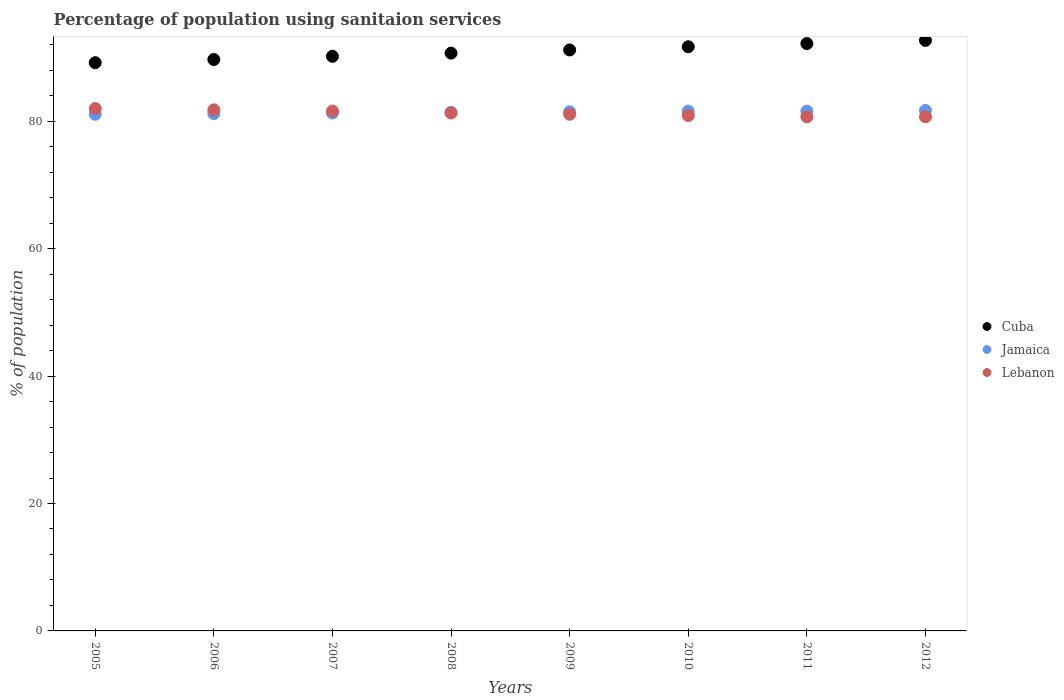What is the percentage of population using sanitaion services in Cuba in 2009?
Give a very brief answer. 91.2. Across all years, what is the maximum percentage of population using sanitaion services in Jamaica?
Give a very brief answer. 81.7. Across all years, what is the minimum percentage of population using sanitaion services in Lebanon?
Your answer should be very brief. 80.7. In which year was the percentage of population using sanitaion services in Jamaica minimum?
Your answer should be compact. 2005. What is the total percentage of population using sanitaion services in Cuba in the graph?
Offer a very short reply. 727.6. What is the difference between the percentage of population using sanitaion services in Jamaica in 2005 and that in 2008?
Offer a terse response. -0.3. What is the average percentage of population using sanitaion services in Cuba per year?
Keep it short and to the point. 90.95. In the year 2005, what is the difference between the percentage of population using sanitaion services in Cuba and percentage of population using sanitaion services in Lebanon?
Offer a terse response. 7.2. What is the ratio of the percentage of population using sanitaion services in Lebanon in 2005 to that in 2007?
Your response must be concise. 1. What is the difference between the highest and the second highest percentage of population using sanitaion services in Lebanon?
Your answer should be compact. 0.2. What is the difference between the highest and the lowest percentage of population using sanitaion services in Jamaica?
Keep it short and to the point. 0.6. Is it the case that in every year, the sum of the percentage of population using sanitaion services in Jamaica and percentage of population using sanitaion services in Cuba  is greater than the percentage of population using sanitaion services in Lebanon?
Give a very brief answer. Yes. Does the percentage of population using sanitaion services in Jamaica monotonically increase over the years?
Ensure brevity in your answer.  No. Is the percentage of population using sanitaion services in Cuba strictly greater than the percentage of population using sanitaion services in Lebanon over the years?
Ensure brevity in your answer.  Yes. Is the percentage of population using sanitaion services in Lebanon strictly less than the percentage of population using sanitaion services in Cuba over the years?
Offer a terse response. Yes. Are the values on the major ticks of Y-axis written in scientific E-notation?
Offer a very short reply. No. Does the graph contain any zero values?
Provide a succinct answer. No. What is the title of the graph?
Your answer should be compact. Percentage of population using sanitaion services. What is the label or title of the Y-axis?
Keep it short and to the point. % of population. What is the % of population of Cuba in 2005?
Make the answer very short. 89.2. What is the % of population in Jamaica in 2005?
Your answer should be compact. 81.1. What is the % of population of Lebanon in 2005?
Offer a very short reply. 82. What is the % of population in Cuba in 2006?
Offer a terse response. 89.7. What is the % of population in Jamaica in 2006?
Offer a very short reply. 81.2. What is the % of population in Lebanon in 2006?
Your response must be concise. 81.8. What is the % of population in Cuba in 2007?
Your answer should be compact. 90.2. What is the % of population of Jamaica in 2007?
Make the answer very short. 81.3. What is the % of population of Lebanon in 2007?
Ensure brevity in your answer.  81.6. What is the % of population in Cuba in 2008?
Offer a terse response. 90.7. What is the % of population in Jamaica in 2008?
Your response must be concise. 81.4. What is the % of population in Lebanon in 2008?
Your answer should be very brief. 81.3. What is the % of population in Cuba in 2009?
Provide a succinct answer. 91.2. What is the % of population in Jamaica in 2009?
Your response must be concise. 81.5. What is the % of population of Lebanon in 2009?
Provide a succinct answer. 81.1. What is the % of population of Cuba in 2010?
Your answer should be compact. 91.7. What is the % of population in Jamaica in 2010?
Ensure brevity in your answer.  81.6. What is the % of population of Lebanon in 2010?
Make the answer very short. 80.9. What is the % of population of Cuba in 2011?
Ensure brevity in your answer.  92.2. What is the % of population in Jamaica in 2011?
Ensure brevity in your answer.  81.6. What is the % of population of Lebanon in 2011?
Provide a succinct answer. 80.7. What is the % of population of Cuba in 2012?
Your response must be concise. 92.7. What is the % of population of Jamaica in 2012?
Keep it short and to the point. 81.7. What is the % of population in Lebanon in 2012?
Provide a succinct answer. 80.7. Across all years, what is the maximum % of population in Cuba?
Provide a short and direct response. 92.7. Across all years, what is the maximum % of population of Jamaica?
Provide a short and direct response. 81.7. Across all years, what is the maximum % of population in Lebanon?
Keep it short and to the point. 82. Across all years, what is the minimum % of population in Cuba?
Give a very brief answer. 89.2. Across all years, what is the minimum % of population in Jamaica?
Ensure brevity in your answer.  81.1. Across all years, what is the minimum % of population of Lebanon?
Make the answer very short. 80.7. What is the total % of population in Cuba in the graph?
Give a very brief answer. 727.6. What is the total % of population in Jamaica in the graph?
Your answer should be very brief. 651.4. What is the total % of population of Lebanon in the graph?
Make the answer very short. 650.1. What is the difference between the % of population of Jamaica in 2005 and that in 2006?
Ensure brevity in your answer.  -0.1. What is the difference between the % of population of Lebanon in 2005 and that in 2006?
Keep it short and to the point. 0.2. What is the difference between the % of population of Jamaica in 2005 and that in 2007?
Ensure brevity in your answer.  -0.2. What is the difference between the % of population of Lebanon in 2005 and that in 2008?
Your answer should be compact. 0.7. What is the difference between the % of population in Lebanon in 2005 and that in 2009?
Provide a short and direct response. 0.9. What is the difference between the % of population of Cuba in 2005 and that in 2010?
Offer a very short reply. -2.5. What is the difference between the % of population of Jamaica in 2005 and that in 2010?
Your answer should be compact. -0.5. What is the difference between the % of population of Lebanon in 2005 and that in 2010?
Provide a succinct answer. 1.1. What is the difference between the % of population of Cuba in 2005 and that in 2011?
Provide a succinct answer. -3. What is the difference between the % of population of Cuba in 2005 and that in 2012?
Offer a very short reply. -3.5. What is the difference between the % of population of Jamaica in 2005 and that in 2012?
Your answer should be compact. -0.6. What is the difference between the % of population of Lebanon in 2006 and that in 2007?
Provide a succinct answer. 0.2. What is the difference between the % of population in Jamaica in 2006 and that in 2008?
Keep it short and to the point. -0.2. What is the difference between the % of population of Lebanon in 2006 and that in 2008?
Provide a short and direct response. 0.5. What is the difference between the % of population of Jamaica in 2006 and that in 2009?
Your answer should be compact. -0.3. What is the difference between the % of population of Cuba in 2006 and that in 2010?
Provide a succinct answer. -2. What is the difference between the % of population in Jamaica in 2006 and that in 2010?
Your response must be concise. -0.4. What is the difference between the % of population of Lebanon in 2006 and that in 2010?
Give a very brief answer. 0.9. What is the difference between the % of population in Lebanon in 2006 and that in 2011?
Provide a succinct answer. 1.1. What is the difference between the % of population in Cuba in 2006 and that in 2012?
Ensure brevity in your answer.  -3. What is the difference between the % of population of Lebanon in 2006 and that in 2012?
Provide a short and direct response. 1.1. What is the difference between the % of population of Jamaica in 2007 and that in 2008?
Ensure brevity in your answer.  -0.1. What is the difference between the % of population in Lebanon in 2007 and that in 2008?
Offer a terse response. 0.3. What is the difference between the % of population of Cuba in 2007 and that in 2009?
Keep it short and to the point. -1. What is the difference between the % of population of Cuba in 2007 and that in 2010?
Keep it short and to the point. -1.5. What is the difference between the % of population of Jamaica in 2007 and that in 2011?
Keep it short and to the point. -0.3. What is the difference between the % of population of Jamaica in 2008 and that in 2009?
Keep it short and to the point. -0.1. What is the difference between the % of population of Cuba in 2008 and that in 2010?
Keep it short and to the point. -1. What is the difference between the % of population in Lebanon in 2008 and that in 2010?
Keep it short and to the point. 0.4. What is the difference between the % of population in Cuba in 2008 and that in 2011?
Give a very brief answer. -1.5. What is the difference between the % of population of Jamaica in 2008 and that in 2011?
Your answer should be very brief. -0.2. What is the difference between the % of population in Lebanon in 2008 and that in 2011?
Your response must be concise. 0.6. What is the difference between the % of population in Jamaica in 2008 and that in 2012?
Offer a terse response. -0.3. What is the difference between the % of population in Lebanon in 2008 and that in 2012?
Provide a succinct answer. 0.6. What is the difference between the % of population of Cuba in 2009 and that in 2010?
Make the answer very short. -0.5. What is the difference between the % of population in Jamaica in 2009 and that in 2010?
Your response must be concise. -0.1. What is the difference between the % of population in Lebanon in 2009 and that in 2010?
Provide a succinct answer. 0.2. What is the difference between the % of population in Cuba in 2009 and that in 2011?
Offer a terse response. -1. What is the difference between the % of population in Jamaica in 2009 and that in 2012?
Keep it short and to the point. -0.2. What is the difference between the % of population of Lebanon in 2009 and that in 2012?
Your response must be concise. 0.4. What is the difference between the % of population of Cuba in 2010 and that in 2011?
Offer a very short reply. -0.5. What is the difference between the % of population in Jamaica in 2010 and that in 2012?
Make the answer very short. -0.1. What is the difference between the % of population in Lebanon in 2010 and that in 2012?
Give a very brief answer. 0.2. What is the difference between the % of population of Cuba in 2005 and the % of population of Jamaica in 2007?
Keep it short and to the point. 7.9. What is the difference between the % of population of Jamaica in 2005 and the % of population of Lebanon in 2007?
Offer a very short reply. -0.5. What is the difference between the % of population of Cuba in 2005 and the % of population of Jamaica in 2008?
Offer a terse response. 7.8. What is the difference between the % of population in Cuba in 2005 and the % of population in Lebanon in 2008?
Your answer should be compact. 7.9. What is the difference between the % of population in Jamaica in 2005 and the % of population in Lebanon in 2009?
Provide a succinct answer. 0. What is the difference between the % of population in Cuba in 2005 and the % of population in Jamaica in 2010?
Provide a short and direct response. 7.6. What is the difference between the % of population in Jamaica in 2005 and the % of population in Lebanon in 2010?
Provide a succinct answer. 0.2. What is the difference between the % of population in Cuba in 2005 and the % of population in Jamaica in 2011?
Make the answer very short. 7.6. What is the difference between the % of population in Jamaica in 2005 and the % of population in Lebanon in 2011?
Keep it short and to the point. 0.4. What is the difference between the % of population in Cuba in 2005 and the % of population in Lebanon in 2012?
Make the answer very short. 8.5. What is the difference between the % of population of Jamaica in 2005 and the % of population of Lebanon in 2012?
Give a very brief answer. 0.4. What is the difference between the % of population of Cuba in 2006 and the % of population of Lebanon in 2007?
Ensure brevity in your answer.  8.1. What is the difference between the % of population of Cuba in 2006 and the % of population of Jamaica in 2009?
Provide a succinct answer. 8.2. What is the difference between the % of population of Cuba in 2006 and the % of population of Lebanon in 2009?
Keep it short and to the point. 8.6. What is the difference between the % of population in Jamaica in 2006 and the % of population in Lebanon in 2009?
Keep it short and to the point. 0.1. What is the difference between the % of population in Cuba in 2006 and the % of population in Jamaica in 2010?
Provide a short and direct response. 8.1. What is the difference between the % of population of Cuba in 2006 and the % of population of Lebanon in 2010?
Offer a terse response. 8.8. What is the difference between the % of population of Jamaica in 2006 and the % of population of Lebanon in 2010?
Your answer should be compact. 0.3. What is the difference between the % of population of Cuba in 2006 and the % of population of Jamaica in 2011?
Your answer should be very brief. 8.1. What is the difference between the % of population in Jamaica in 2006 and the % of population in Lebanon in 2011?
Your answer should be very brief. 0.5. What is the difference between the % of population in Cuba in 2006 and the % of population in Jamaica in 2012?
Give a very brief answer. 8. What is the difference between the % of population of Jamaica in 2007 and the % of population of Lebanon in 2008?
Provide a succinct answer. 0. What is the difference between the % of population of Cuba in 2007 and the % of population of Jamaica in 2009?
Ensure brevity in your answer.  8.7. What is the difference between the % of population of Cuba in 2007 and the % of population of Lebanon in 2010?
Provide a short and direct response. 9.3. What is the difference between the % of population in Jamaica in 2007 and the % of population in Lebanon in 2010?
Give a very brief answer. 0.4. What is the difference between the % of population in Jamaica in 2007 and the % of population in Lebanon in 2011?
Offer a very short reply. 0.6. What is the difference between the % of population in Cuba in 2007 and the % of population in Jamaica in 2012?
Provide a succinct answer. 8.5. What is the difference between the % of population in Cuba in 2007 and the % of population in Lebanon in 2012?
Offer a very short reply. 9.5. What is the difference between the % of population in Cuba in 2008 and the % of population in Lebanon in 2011?
Your answer should be compact. 10. What is the difference between the % of population in Jamaica in 2008 and the % of population in Lebanon in 2011?
Your answer should be compact. 0.7. What is the difference between the % of population in Cuba in 2008 and the % of population in Jamaica in 2012?
Offer a terse response. 9. What is the difference between the % of population in Cuba in 2008 and the % of population in Lebanon in 2012?
Give a very brief answer. 10. What is the difference between the % of population in Jamaica in 2008 and the % of population in Lebanon in 2012?
Ensure brevity in your answer.  0.7. What is the difference between the % of population of Cuba in 2009 and the % of population of Jamaica in 2010?
Keep it short and to the point. 9.6. What is the difference between the % of population in Cuba in 2009 and the % of population in Lebanon in 2010?
Give a very brief answer. 10.3. What is the difference between the % of population in Cuba in 2009 and the % of population in Jamaica in 2011?
Ensure brevity in your answer.  9.6. What is the difference between the % of population of Cuba in 2009 and the % of population of Lebanon in 2011?
Offer a very short reply. 10.5. What is the difference between the % of population in Cuba in 2009 and the % of population in Jamaica in 2012?
Offer a terse response. 9.5. What is the difference between the % of population in Cuba in 2009 and the % of population in Lebanon in 2012?
Ensure brevity in your answer.  10.5. What is the difference between the % of population in Cuba in 2010 and the % of population in Jamaica in 2011?
Offer a terse response. 10.1. What is the difference between the % of population of Cuba in 2010 and the % of population of Lebanon in 2012?
Provide a short and direct response. 11. What is the difference between the % of population in Cuba in 2011 and the % of population in Jamaica in 2012?
Ensure brevity in your answer.  10.5. What is the difference between the % of population in Cuba in 2011 and the % of population in Lebanon in 2012?
Your response must be concise. 11.5. What is the difference between the % of population in Jamaica in 2011 and the % of population in Lebanon in 2012?
Your answer should be compact. 0.9. What is the average % of population of Cuba per year?
Give a very brief answer. 90.95. What is the average % of population of Jamaica per year?
Offer a terse response. 81.42. What is the average % of population in Lebanon per year?
Offer a very short reply. 81.26. In the year 2006, what is the difference between the % of population in Cuba and % of population in Lebanon?
Provide a succinct answer. 7.9. In the year 2006, what is the difference between the % of population of Jamaica and % of population of Lebanon?
Make the answer very short. -0.6. In the year 2007, what is the difference between the % of population of Cuba and % of population of Jamaica?
Offer a very short reply. 8.9. In the year 2008, what is the difference between the % of population in Cuba and % of population in Lebanon?
Offer a terse response. 9.4. In the year 2008, what is the difference between the % of population in Jamaica and % of population in Lebanon?
Your answer should be very brief. 0.1. In the year 2009, what is the difference between the % of population of Cuba and % of population of Lebanon?
Provide a short and direct response. 10.1. In the year 2010, what is the difference between the % of population of Cuba and % of population of Jamaica?
Offer a very short reply. 10.1. In the year 2011, what is the difference between the % of population of Cuba and % of population of Jamaica?
Provide a succinct answer. 10.6. What is the ratio of the % of population of Cuba in 2005 to that in 2006?
Give a very brief answer. 0.99. What is the ratio of the % of population in Cuba in 2005 to that in 2007?
Keep it short and to the point. 0.99. What is the ratio of the % of population of Lebanon in 2005 to that in 2007?
Make the answer very short. 1. What is the ratio of the % of population in Cuba in 2005 to that in 2008?
Keep it short and to the point. 0.98. What is the ratio of the % of population in Jamaica in 2005 to that in 2008?
Give a very brief answer. 1. What is the ratio of the % of population of Lebanon in 2005 to that in 2008?
Offer a terse response. 1.01. What is the ratio of the % of population in Cuba in 2005 to that in 2009?
Offer a terse response. 0.98. What is the ratio of the % of population of Lebanon in 2005 to that in 2009?
Make the answer very short. 1.01. What is the ratio of the % of population of Cuba in 2005 to that in 2010?
Your answer should be very brief. 0.97. What is the ratio of the % of population in Jamaica in 2005 to that in 2010?
Provide a short and direct response. 0.99. What is the ratio of the % of population in Lebanon in 2005 to that in 2010?
Provide a short and direct response. 1.01. What is the ratio of the % of population of Cuba in 2005 to that in 2011?
Offer a very short reply. 0.97. What is the ratio of the % of population of Lebanon in 2005 to that in 2011?
Offer a very short reply. 1.02. What is the ratio of the % of population in Cuba in 2005 to that in 2012?
Keep it short and to the point. 0.96. What is the ratio of the % of population in Lebanon in 2005 to that in 2012?
Keep it short and to the point. 1.02. What is the ratio of the % of population in Cuba in 2006 to that in 2007?
Your answer should be very brief. 0.99. What is the ratio of the % of population of Jamaica in 2006 to that in 2007?
Your answer should be very brief. 1. What is the ratio of the % of population in Cuba in 2006 to that in 2008?
Provide a short and direct response. 0.99. What is the ratio of the % of population in Lebanon in 2006 to that in 2008?
Give a very brief answer. 1.01. What is the ratio of the % of population in Cuba in 2006 to that in 2009?
Offer a terse response. 0.98. What is the ratio of the % of population in Lebanon in 2006 to that in 2009?
Offer a very short reply. 1.01. What is the ratio of the % of population in Cuba in 2006 to that in 2010?
Your answer should be very brief. 0.98. What is the ratio of the % of population of Lebanon in 2006 to that in 2010?
Give a very brief answer. 1.01. What is the ratio of the % of population of Cuba in 2006 to that in 2011?
Give a very brief answer. 0.97. What is the ratio of the % of population in Jamaica in 2006 to that in 2011?
Your response must be concise. 1. What is the ratio of the % of population of Lebanon in 2006 to that in 2011?
Provide a succinct answer. 1.01. What is the ratio of the % of population in Cuba in 2006 to that in 2012?
Make the answer very short. 0.97. What is the ratio of the % of population in Jamaica in 2006 to that in 2012?
Provide a succinct answer. 0.99. What is the ratio of the % of population in Lebanon in 2006 to that in 2012?
Keep it short and to the point. 1.01. What is the ratio of the % of population of Lebanon in 2007 to that in 2008?
Offer a terse response. 1. What is the ratio of the % of population of Cuba in 2007 to that in 2009?
Provide a short and direct response. 0.99. What is the ratio of the % of population of Jamaica in 2007 to that in 2009?
Keep it short and to the point. 1. What is the ratio of the % of population in Lebanon in 2007 to that in 2009?
Give a very brief answer. 1.01. What is the ratio of the % of population of Cuba in 2007 to that in 2010?
Provide a short and direct response. 0.98. What is the ratio of the % of population of Jamaica in 2007 to that in 2010?
Your answer should be very brief. 1. What is the ratio of the % of population of Lebanon in 2007 to that in 2010?
Keep it short and to the point. 1.01. What is the ratio of the % of population in Cuba in 2007 to that in 2011?
Offer a very short reply. 0.98. What is the ratio of the % of population in Lebanon in 2007 to that in 2011?
Make the answer very short. 1.01. What is the ratio of the % of population of Lebanon in 2007 to that in 2012?
Your answer should be very brief. 1.01. What is the ratio of the % of population in Jamaica in 2008 to that in 2009?
Offer a terse response. 1. What is the ratio of the % of population in Cuba in 2008 to that in 2010?
Provide a short and direct response. 0.99. What is the ratio of the % of population of Jamaica in 2008 to that in 2010?
Provide a succinct answer. 1. What is the ratio of the % of population of Lebanon in 2008 to that in 2010?
Ensure brevity in your answer.  1. What is the ratio of the % of population in Cuba in 2008 to that in 2011?
Give a very brief answer. 0.98. What is the ratio of the % of population in Lebanon in 2008 to that in 2011?
Your answer should be very brief. 1.01. What is the ratio of the % of population of Cuba in 2008 to that in 2012?
Offer a terse response. 0.98. What is the ratio of the % of population in Lebanon in 2008 to that in 2012?
Give a very brief answer. 1.01. What is the ratio of the % of population of Jamaica in 2009 to that in 2011?
Your response must be concise. 1. What is the ratio of the % of population of Cuba in 2009 to that in 2012?
Give a very brief answer. 0.98. What is the ratio of the % of population of Cuba in 2010 to that in 2012?
Offer a very short reply. 0.99. What is the ratio of the % of population in Jamaica in 2011 to that in 2012?
Your answer should be compact. 1. What is the difference between the highest and the second highest % of population in Cuba?
Make the answer very short. 0.5. What is the difference between the highest and the lowest % of population in Cuba?
Provide a succinct answer. 3.5. 